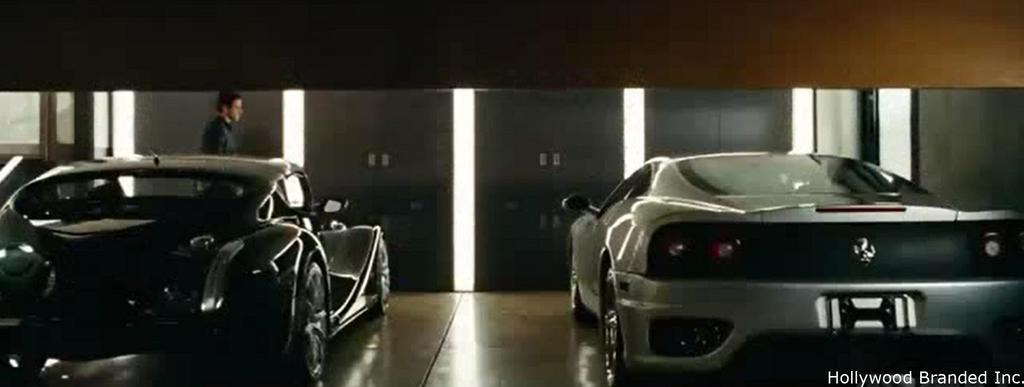How would you summarize this image in a sentence or two? In the foreground of this image, there are two cars on the floor and a man walking behind it and there is also a wall and lights in the background. On the top, there is a cardboard sheet. 